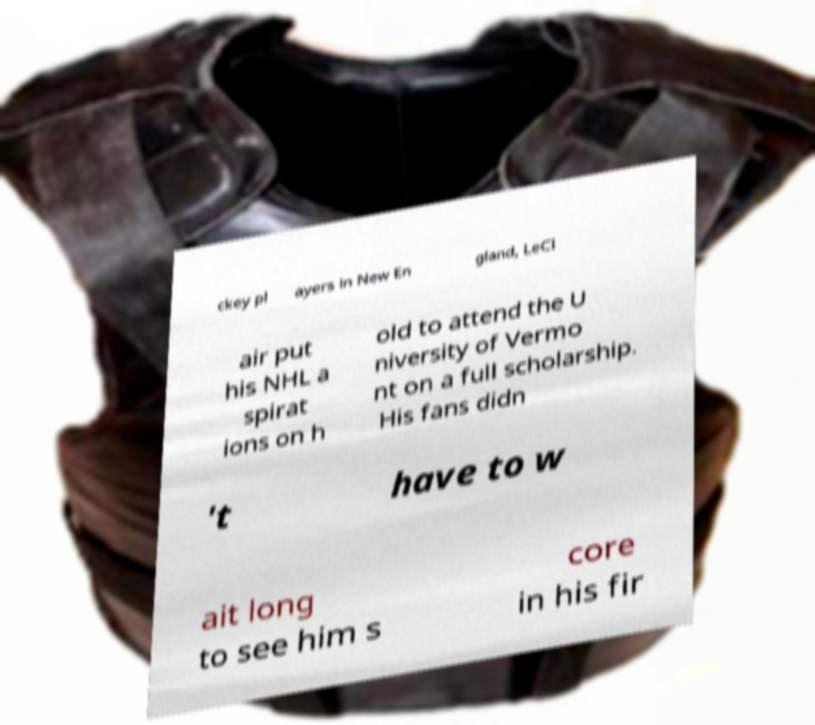What messages or text are displayed in this image? I need them in a readable, typed format. ckey pl ayers in New En gland, LeCl air put his NHL a spirat ions on h old to attend the U niversity of Vermo nt on a full scholarship. His fans didn 't have to w ait long to see him s core in his fir 